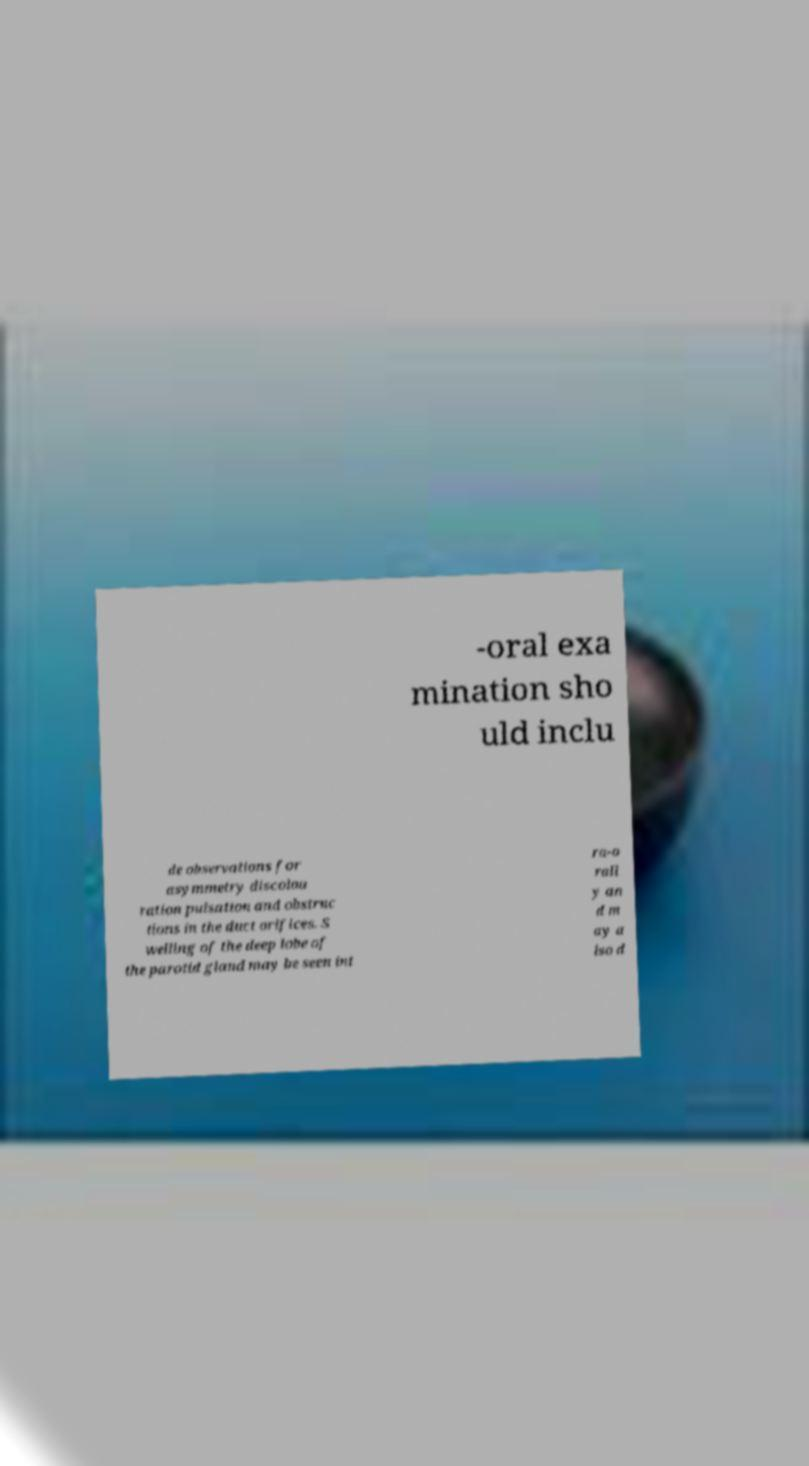Could you assist in decoding the text presented in this image and type it out clearly? -oral exa mination sho uld inclu de observations for asymmetry discolou ration pulsation and obstruc tions in the duct orifices. S welling of the deep lobe of the parotid gland may be seen int ra-o rall y an d m ay a lso d 